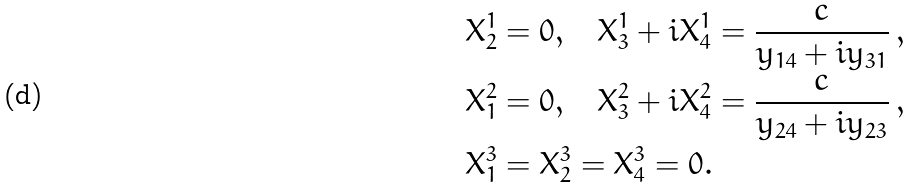Convert formula to latex. <formula><loc_0><loc_0><loc_500><loc_500>X ^ { 1 } _ { 2 } & = 0 , \quad X ^ { 1 } _ { 3 } + i X ^ { 1 } _ { 4 } = \frac { c } { y _ { 1 4 } + i y _ { 3 1 } } \, , \\ X ^ { 2 } _ { 1 } & = 0 , \quad X ^ { 2 } _ { 3 } + i X ^ { 2 } _ { 4 } = \frac { c } { y _ { 2 4 } + i y _ { 2 3 } } \, , \\ X ^ { 3 } _ { 1 } & = X ^ { 3 } _ { 2 } = X ^ { 3 } _ { 4 } = 0 .</formula> 